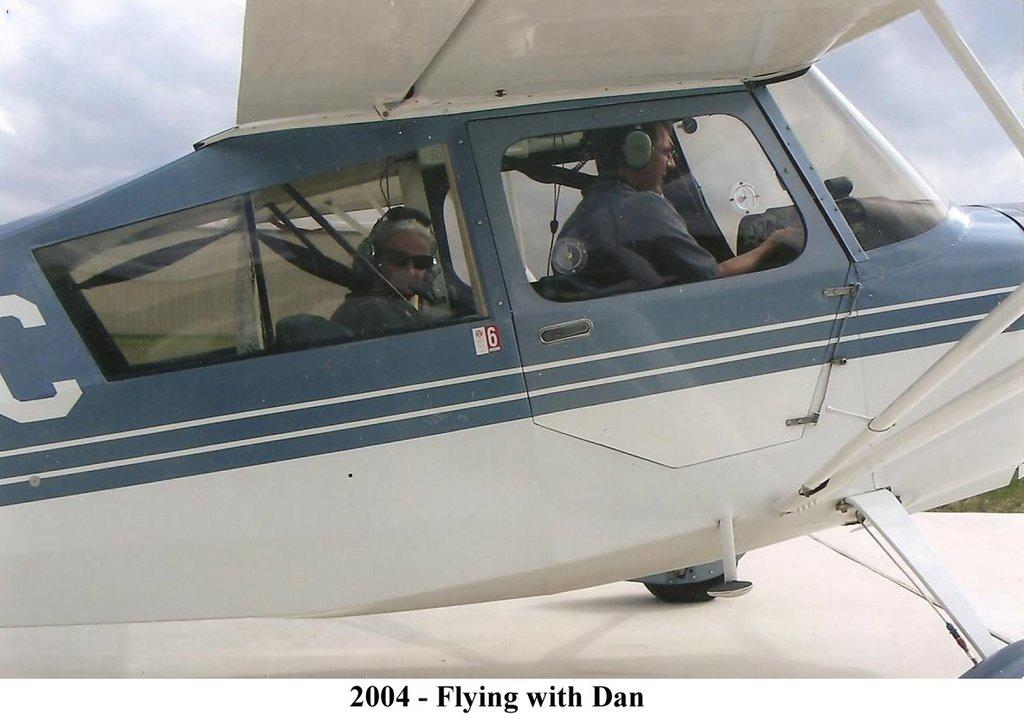What is the main subject of the image? The main subject of the image is persons in an aeroplane. What can be seen in the background of the image? The sky is visible in the background of the image, and clouds are present. Where is the cobweb located in the image? There is no cobweb present in the image. What invention is being used by the persons in the aeroplane? The image does not provide information about any specific inventions being used by the persons in the aeroplane. 